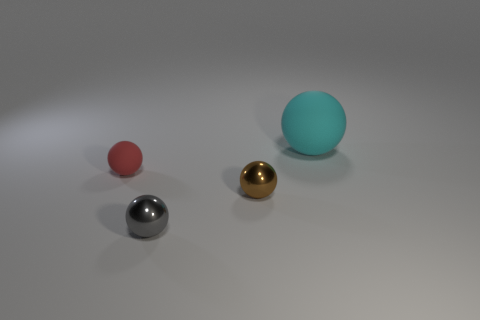Add 3 small red matte things. How many objects exist? 7 Subtract all cyan matte balls. How many balls are left? 3 Subtract 1 spheres. How many spheres are left? 3 Add 2 metal balls. How many metal balls are left? 4 Add 1 tiny blue cylinders. How many tiny blue cylinders exist? 1 Subtract all gray spheres. How many spheres are left? 3 Subtract 0 brown cylinders. How many objects are left? 4 Subtract all cyan balls. Subtract all gray cubes. How many balls are left? 3 Subtract all purple blocks. How many gray spheres are left? 1 Subtract all purple spheres. Subtract all small gray metallic balls. How many objects are left? 3 